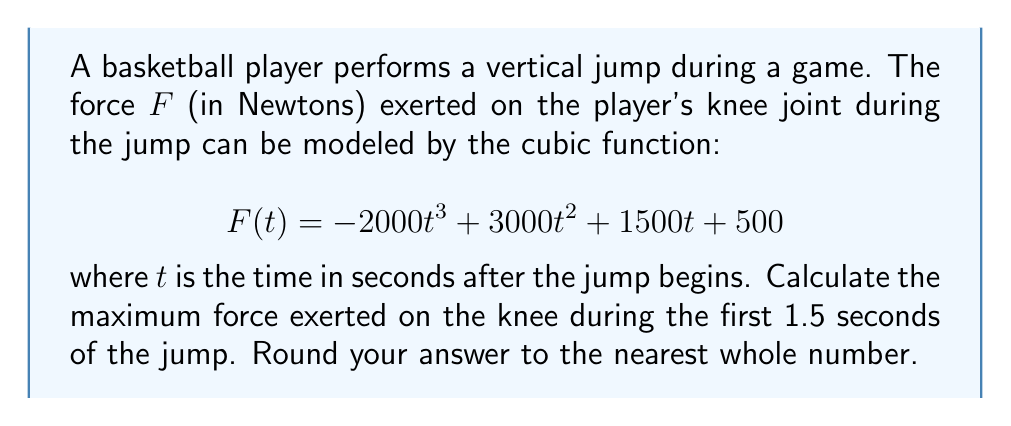Help me with this question. To find the maximum force exerted on the knee, we need to follow these steps:

1) First, we need to find the critical points of the function by taking the derivative and setting it equal to zero:

   $$F'(t) = -6000t^2 + 6000t + 1500$$
   $$-6000t^2 + 6000t + 1500 = 0$$

2) This is a quadratic equation. We can solve it using the quadratic formula:

   $$t = \frac{-b \pm \sqrt{b^2 - 4ac}}{2a}$$

   Where $a = -6000$, $b = 6000$, and $c = 1500$

3) Plugging in these values:

   $$t = \frac{-6000 \pm \sqrt{6000^2 - 4(-6000)(1500)}}{2(-6000)}$$
   $$= \frac{-6000 \pm \sqrt{36,000,000 + 36,000,000}}{-12000}$$
   $$= \frac{-6000 \pm \sqrt{72,000,000}}{-12000}$$
   $$= \frac{-6000 \pm 8485.28}{-12000}$$

4) This gives us two critical points:
   
   $$t_1 = \frac{-6000 + 8485.28}{-12000} \approx 0.2071$$
   $$t_2 = \frac{-6000 - 8485.28}{-12000} \approx 1.2071$$

5) We need to check these critical points, as well as the endpoints of our interval (0 and 1.5 seconds):

   $$F(0) = 500$$
   $$F(0.2071) \approx 1366.67$$
   $$F(1.2071) \approx 2008.33$$
   $$F(1.5) \approx 1750$$

6) The maximum value among these is approximately 2008.33 N, which occurs at t ≈ 1.2071 seconds.

7) Rounding to the nearest whole number, we get 2008 N.
Answer: 2008 N 